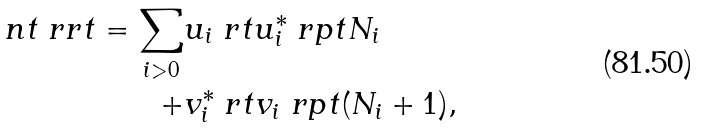<formula> <loc_0><loc_0><loc_500><loc_500>\ n t \ r r t = \sum _ { i > 0 } & u _ { i } \ r t u _ { i } ^ { * } \ r p t N _ { i } \\ + & v _ { i } ^ { * } \ r t v _ { i } \ r p t ( N _ { i } + 1 ) ,</formula> 